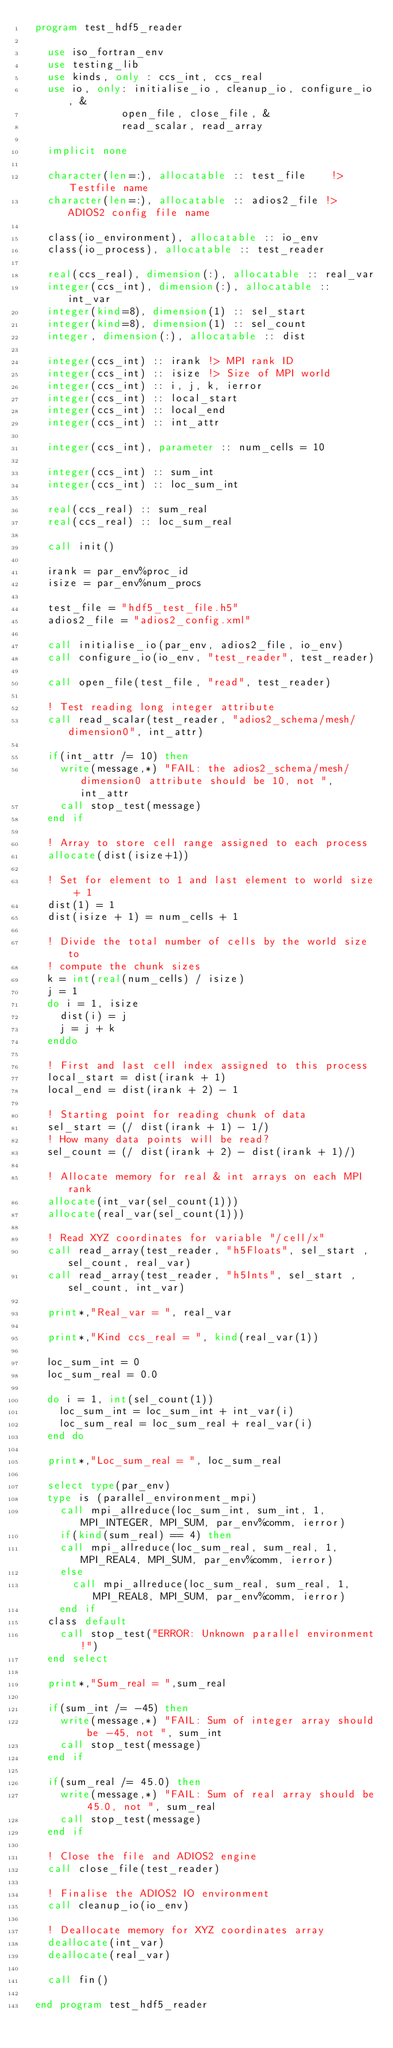Convert code to text. <code><loc_0><loc_0><loc_500><loc_500><_FORTRAN_>  program test_hdf5_reader

    use iso_fortran_env
    use testing_lib
    use kinds, only : ccs_int, ccs_real
    use io, only: initialise_io, cleanup_io, configure_io, &
                open_file, close_file, &
                read_scalar, read_array
    
    implicit none

    character(len=:), allocatable :: test_file    !> Testfile name
    character(len=:), allocatable :: adios2_file !> ADIOS2 config file name
  
    class(io_environment), allocatable :: io_env
    class(io_process), allocatable :: test_reader
  
    real(ccs_real), dimension(:), allocatable :: real_var
    integer(ccs_int), dimension(:), allocatable :: int_var
    integer(kind=8), dimension(1) :: sel_start
    integer(kind=8), dimension(1) :: sel_count
    integer, dimension(:), allocatable :: dist
  
    integer(ccs_int) :: irank !> MPI rank ID
    integer(ccs_int) :: isize !> Size of MPI world
    integer(ccs_int) :: i, j, k, ierror 
    integer(ccs_int) :: local_start
    integer(ccs_int) :: local_end
    integer(ccs_int) :: int_attr

    integer(ccs_int), parameter :: num_cells = 10

    integer(ccs_int) :: sum_int
    integer(ccs_int) :: loc_sum_int

    real(ccs_real) :: sum_real
    real(ccs_real) :: loc_sum_real

    call init()

    irank = par_env%proc_id
    isize = par_env%num_procs
  
    test_file = "hdf5_test_file.h5"
    adios2_file = "adios2_config.xml"
  
    call initialise_io(par_env, adios2_file, io_env)
    call configure_io(io_env, "test_reader", test_reader)  
  
    call open_file(test_file, "read", test_reader)
  
    ! Test reading long integer attribute
    call read_scalar(test_reader, "adios2_schema/mesh/dimension0", int_attr)
    
    if(int_attr /= 10) then
      write(message,*) "FAIL: the adios2_schema/mesh/dimension0 attribute should be 10, not ", int_attr
      call stop_test(message)
    end if   

    ! Array to store cell range assigned to each process      
    allocate(dist(isize+1))
  
    ! Set for element to 1 and last element to world size + 1
    dist(1) = 1
    dist(isize + 1) = num_cells + 1
  
    ! Divide the total number of cells by the world size to
    ! compute the chunk sizes
    k = int(real(num_cells) / isize)
    j = 1
    do i = 1, isize
      dist(i) = j
      j = j + k
    enddo
  
    ! First and last cell index assigned to this process
    local_start = dist(irank + 1)
    local_end = dist(irank + 2) - 1

    ! Starting point for reading chunk of data
    sel_start = (/ dist(irank + 1) - 1/)
    ! How many data points will be read?
    sel_count = (/ dist(irank + 2) - dist(irank + 1)/)
  
    ! Allocate memory for real & int arrays on each MPI rank
    allocate(int_var(sel_count(1)))
    allocate(real_var(sel_count(1)))
  
    ! Read XYZ coordinates for variable "/cell/x" 
    call read_array(test_reader, "h5Floats", sel_start , sel_count, real_var)
    call read_array(test_reader, "h5Ints", sel_start , sel_count, int_var)

    print*,"Real_var = ", real_var

    print*,"Kind ccs_real = ", kind(real_var(1))

    loc_sum_int = 0
    loc_sum_real = 0.0

    do i = 1, int(sel_count(1))
      loc_sum_int = loc_sum_int + int_var(i)
      loc_sum_real = loc_sum_real + real_var(i)
    end do

    print*,"Loc_sum_real = ", loc_sum_real

    select type(par_env)
    type is (parallel_environment_mpi)
      call mpi_allreduce(loc_sum_int, sum_int, 1, MPI_INTEGER, MPI_SUM, par_env%comm, ierror)
      if(kind(sum_real) == 4) then
      call mpi_allreduce(loc_sum_real, sum_real, 1, MPI_REAL4, MPI_SUM, par_env%comm, ierror)
      else 
        call mpi_allreduce(loc_sum_real, sum_real, 1, MPI_REAL8, MPI_SUM, par_env%comm, ierror)
      end if
    class default
      call stop_test("ERROR: Unknown parallel environment!")
    end select

    print*,"Sum_real = ",sum_real

    if(sum_int /= -45) then
      write(message,*) "FAIL: Sum of integer array should be -45, not ", sum_int
      call stop_test(message)
    end if
  
    if(sum_real /= 45.0) then
      write(message,*) "FAIL: Sum of real array should be 45.0, not ", sum_real
      call stop_test(message)
    end if

    ! Close the file and ADIOS2 engine
    call close_file(test_reader)
  
    ! Finalise the ADIOS2 IO environment
    call cleanup_io(io_env)
    
    ! Deallocate memory for XYZ coordinates array
    deallocate(int_var)
    deallocate(real_var)

    call fin()

  end program test_hdf5_reader
</code> 